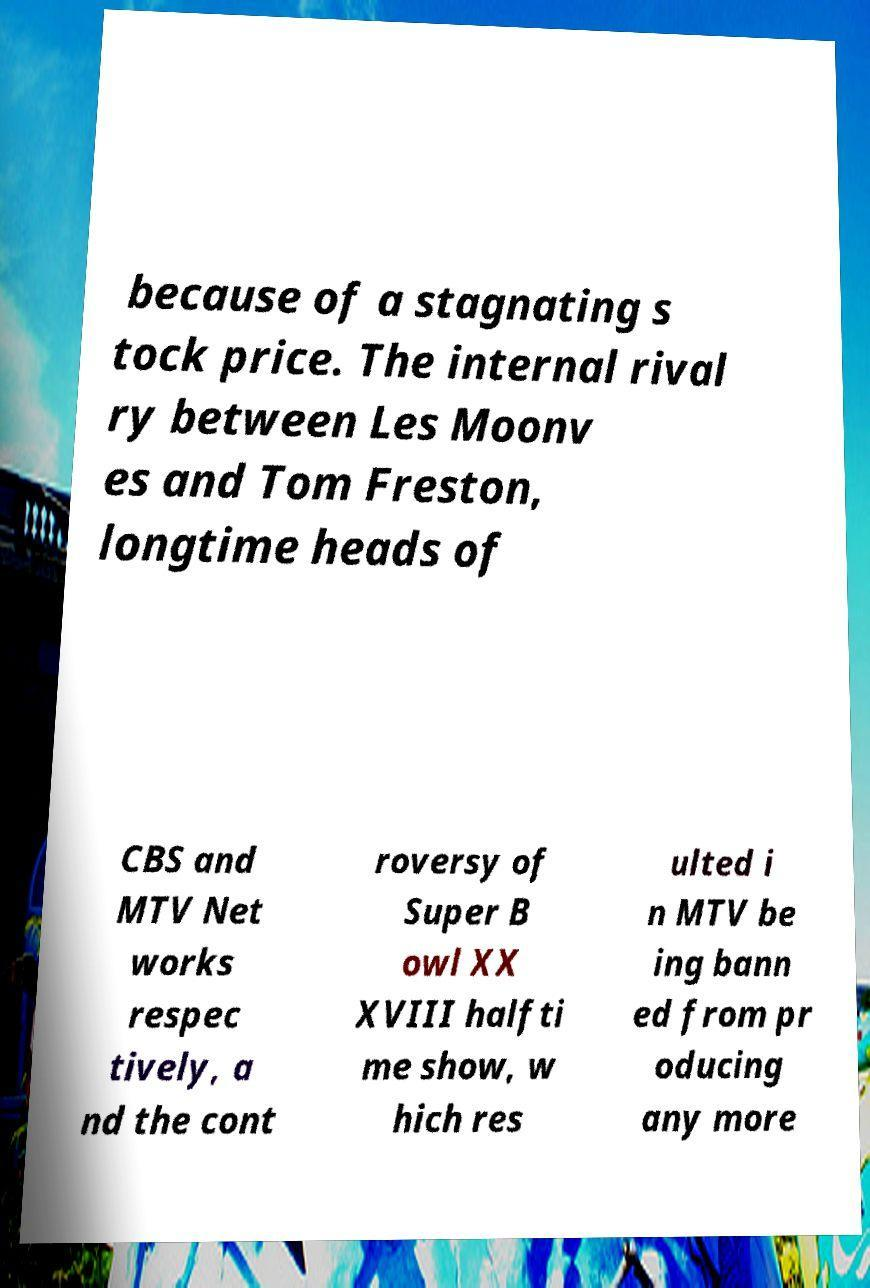Please identify and transcribe the text found in this image. because of a stagnating s tock price. The internal rival ry between Les Moonv es and Tom Freston, longtime heads of CBS and MTV Net works respec tively, a nd the cont roversy of Super B owl XX XVIII halfti me show, w hich res ulted i n MTV be ing bann ed from pr oducing any more 